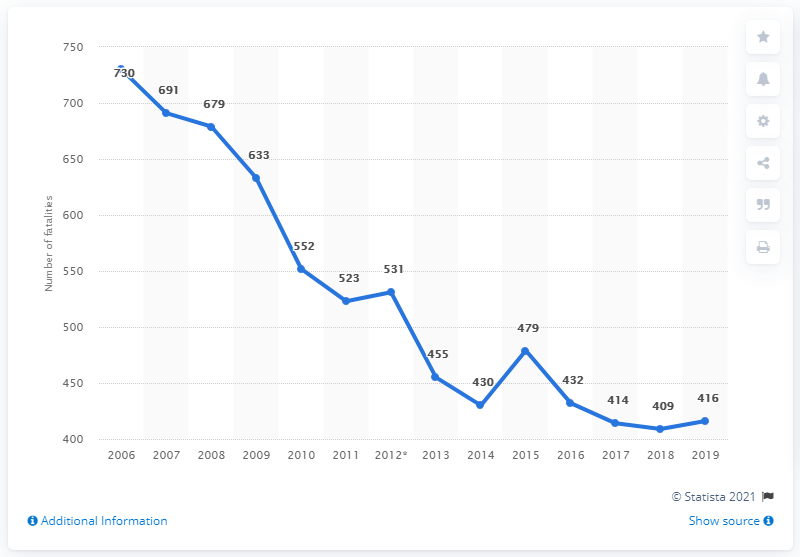List a handful of essential elements in this visual. From 2016 to 2019, the highest number of road traffic fatalities in Austria was 432. At the beginning of the reporting period in 2006, there were 730 traffic fatalities. In 2019, a total of 416 traffic fatalities occurred in Austria. In 2006, there were 730 fatalities on the roads in Austria. 